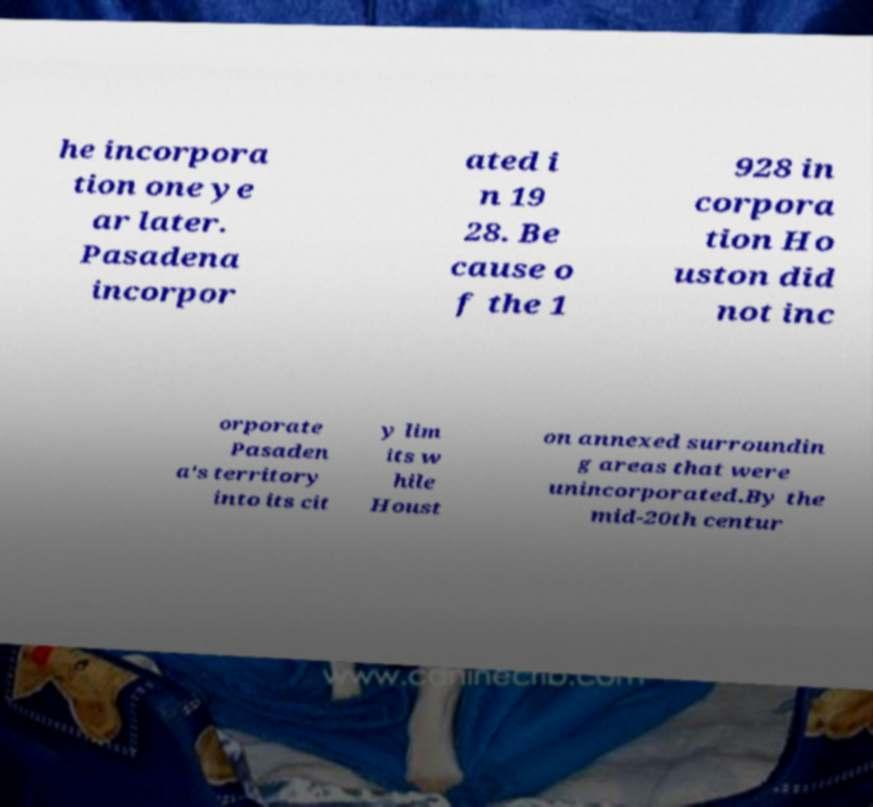For documentation purposes, I need the text within this image transcribed. Could you provide that? he incorpora tion one ye ar later. Pasadena incorpor ated i n 19 28. Be cause o f the 1 928 in corpora tion Ho uston did not inc orporate Pasaden a's territory into its cit y lim its w hile Houst on annexed surroundin g areas that were unincorporated.By the mid-20th centur 